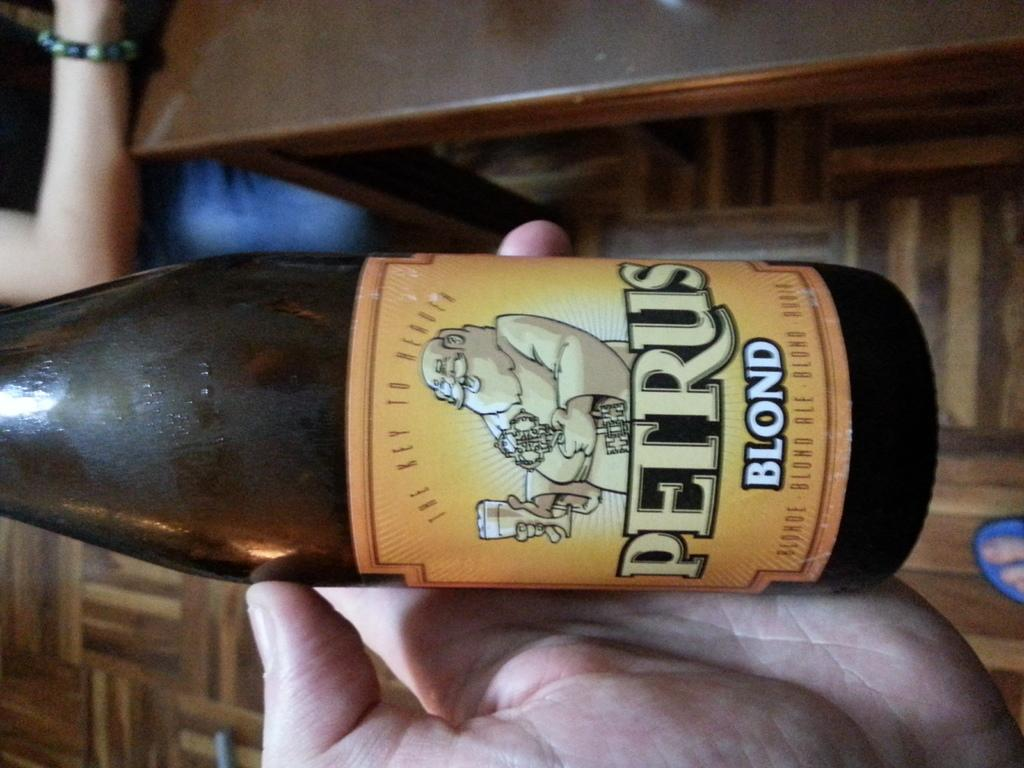<image>
Present a compact description of the photo's key features. the word blond that is on a beer bottle 